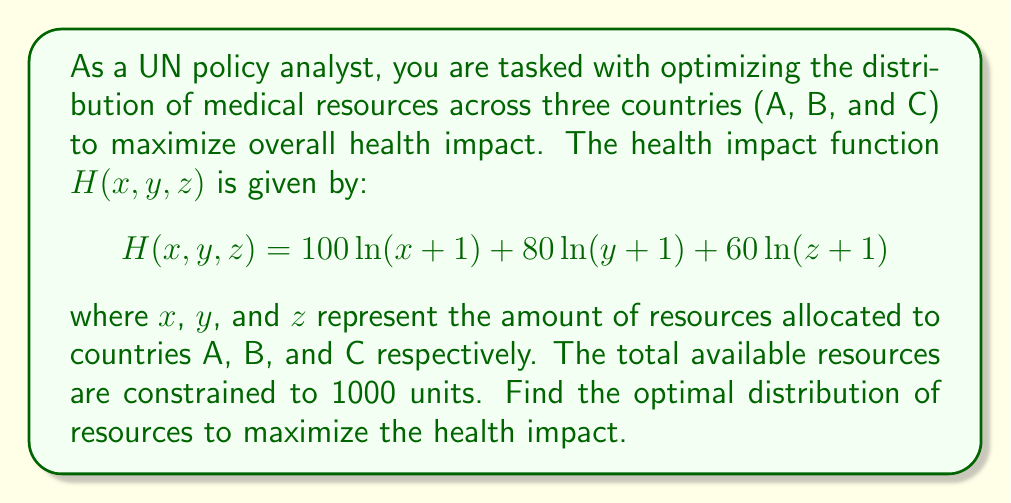What is the answer to this math problem? To solve this multivariable optimization problem, we'll use the method of Lagrange multipliers:

1) First, we set up the Lagrangian function:
   $$L(x, y, z, \lambda) = 100\ln(x+1) + 80\ln(y+1) + 60\ln(z+1) - \lambda(x + y + z - 1000)$$

2) Now, we take partial derivatives and set them equal to zero:

   $$\frac{\partial L}{\partial x} = \frac{100}{x+1} - \lambda = 0$$
   $$\frac{\partial L}{\partial y} = \frac{80}{y+1} - \lambda = 0$$
   $$\frac{\partial L}{\partial z} = \frac{60}{z+1} - \lambda = 0$$
   $$\frac{\partial L}{\partial \lambda} = x + y + z - 1000 = 0$$

3) From the first three equations:
   $$x+1 = \frac{100}{\lambda}$$
   $$y+1 = \frac{80}{\lambda}$$
   $$z+1 = \frac{60}{\lambda}$$

4) Substituting these into the constraint equation:
   $$(\frac{100}{\lambda} - 1) + (\frac{80}{\lambda} - 1) + (\frac{60}{\lambda} - 1) = 1000$$
   $$\frac{240}{\lambda} - 3 = 1000$$
   $$\frac{240}{\lambda} = 1003$$
   $$\lambda = \frac{240}{1003} \approx 0.2393$$

5) Now we can solve for x, y, and z:
   $$x = \frac{100}{\lambda} - 1 \approx 417.3$$
   $$y = \frac{80}{\lambda} - 1 \approx 333.8$$
   $$z = \frac{60}{\lambda} - 1 \approx 250.3$$

6) Rounding to the nearest whole number (as we can't allocate fractional resources):
   x = 417, y = 334, z = 250
Answer: The optimal distribution of medical resources is approximately 417 units to country A, 334 units to country B, and 250 units to country C. 